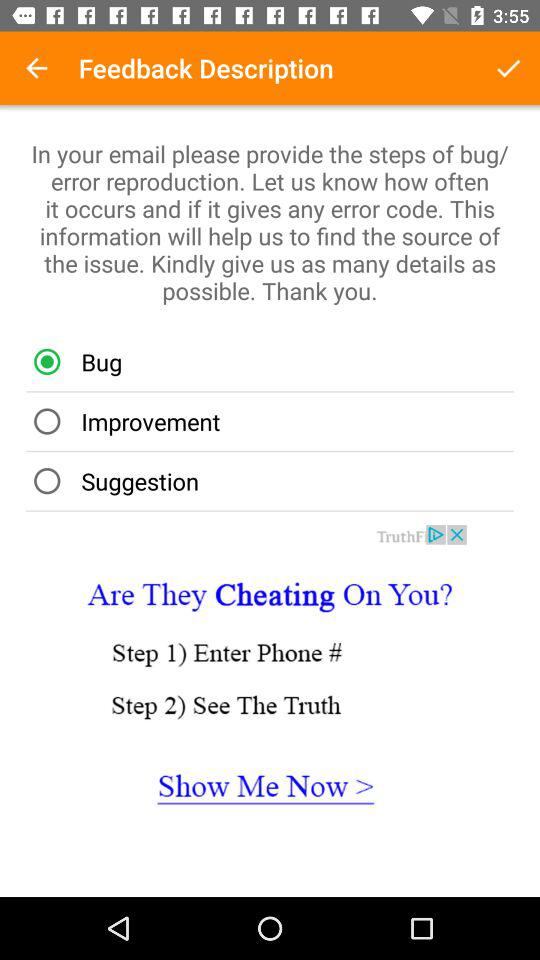How many steps are there in the process of finding out if someone is cheating on you?
Answer the question using a single word or phrase. 2 